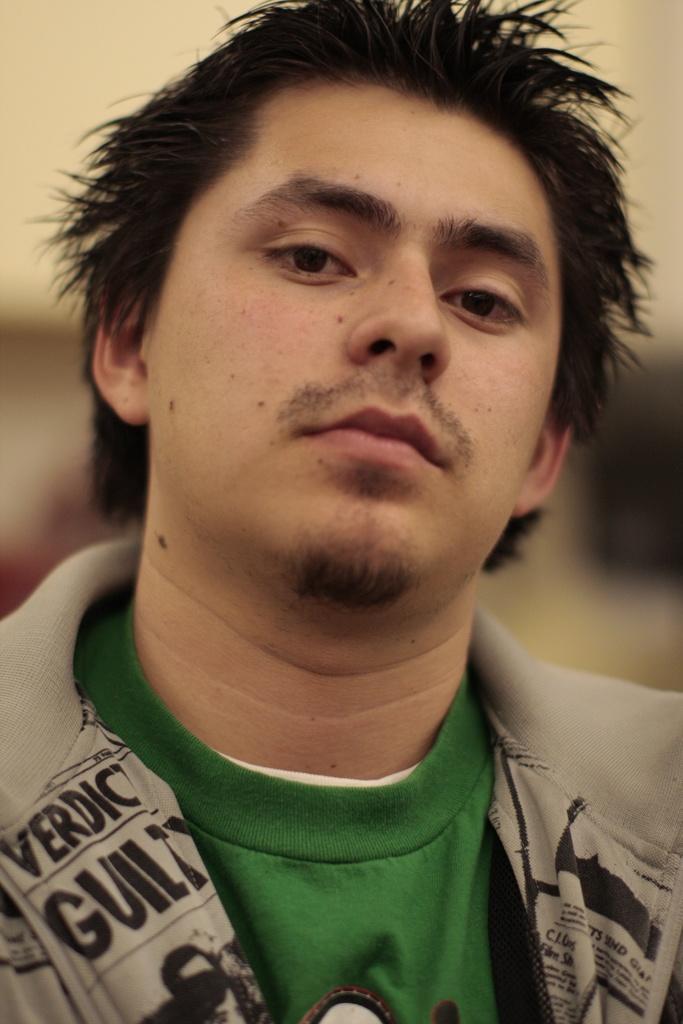Describe this image in one or two sentences. In this picture we can see a man. Behind the man, there is a blurred background. 